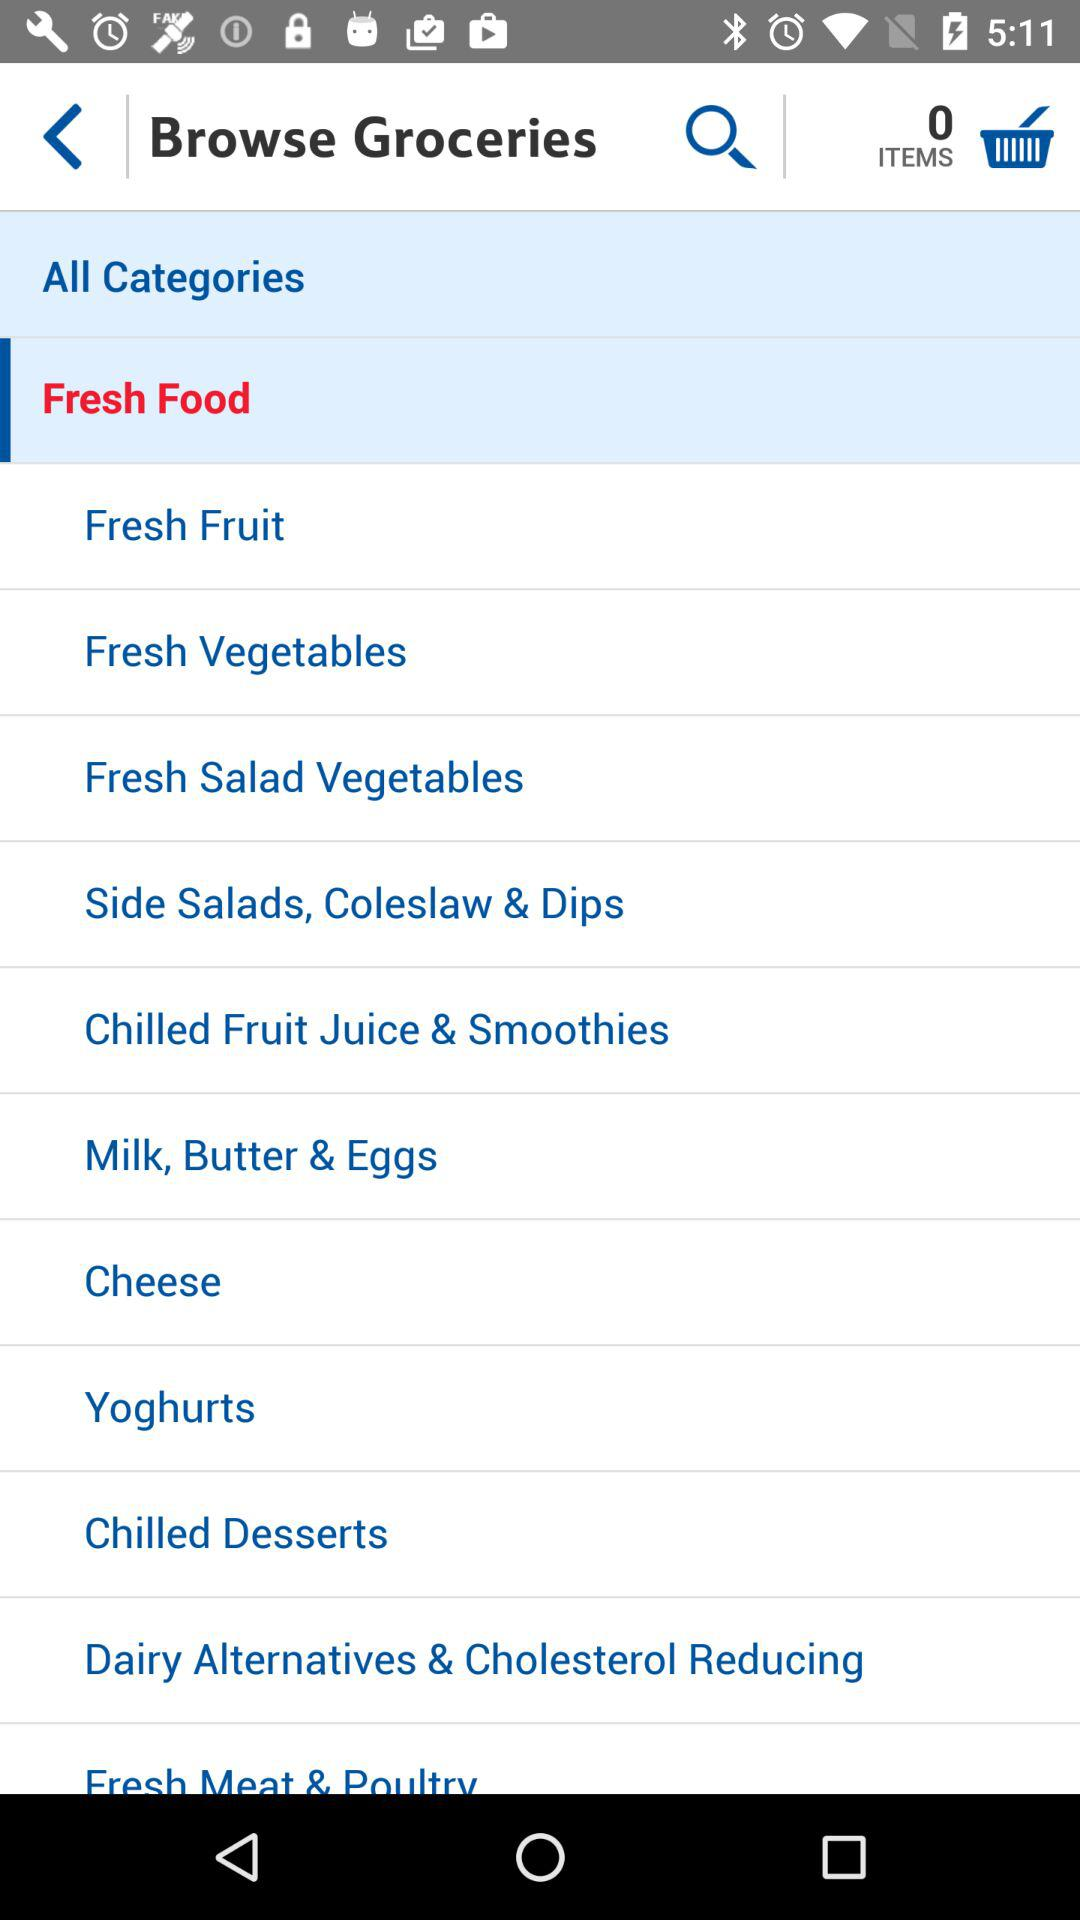How many items are in the cart? There are 0 items in the cart. 